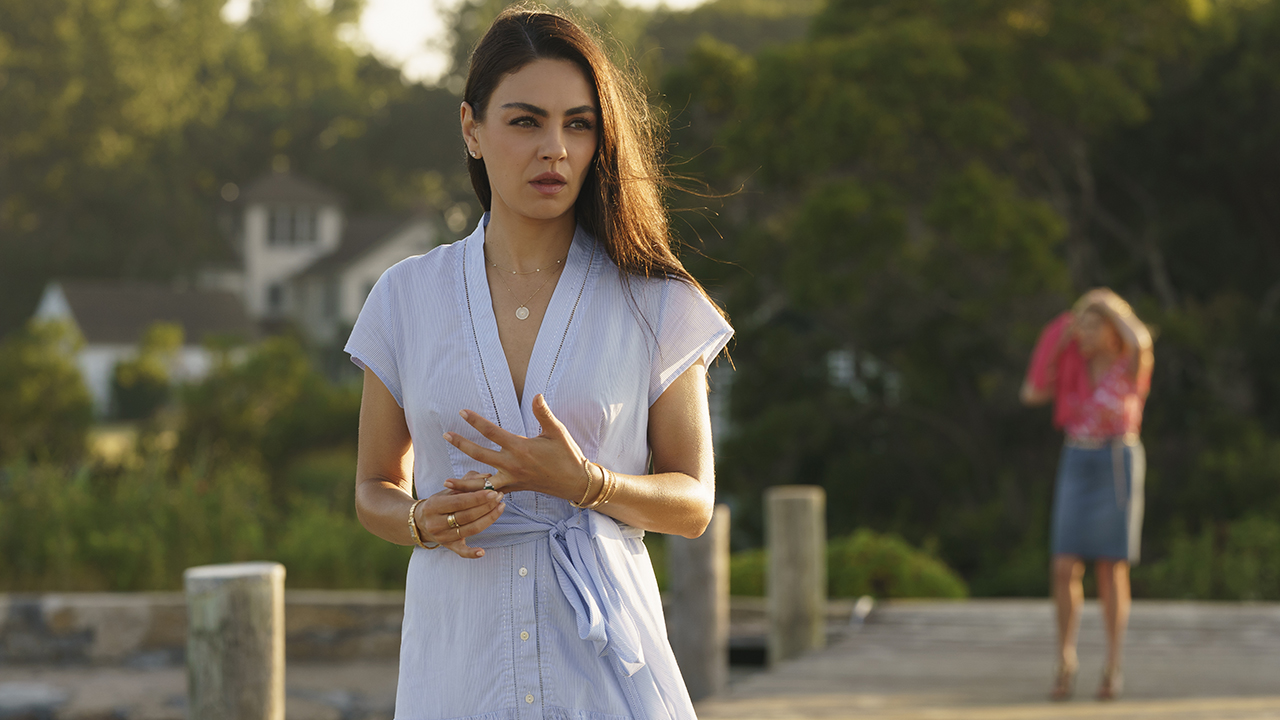What are the key elements in this picture? This image captures a moment of quiet contemplation. In the foreground, a woman is seen standing on a wooden pier, her hands clasped in front of her. She is wearing a light blue dress with a subtle, elegant design, and accessorized with simple jewelry, including a necklace and bracelets. Her expression suggests deep thought, as her gaze is directed to the side, focusing on something out of the frame. In the background, there is another woman dressed in a pink shirt and blue skirt, walking away from the pier towards what appears to be a house in the distance. The scene is set in a serene, natural environment with greenery and a house visible, indicating a peaceful day by the water. 